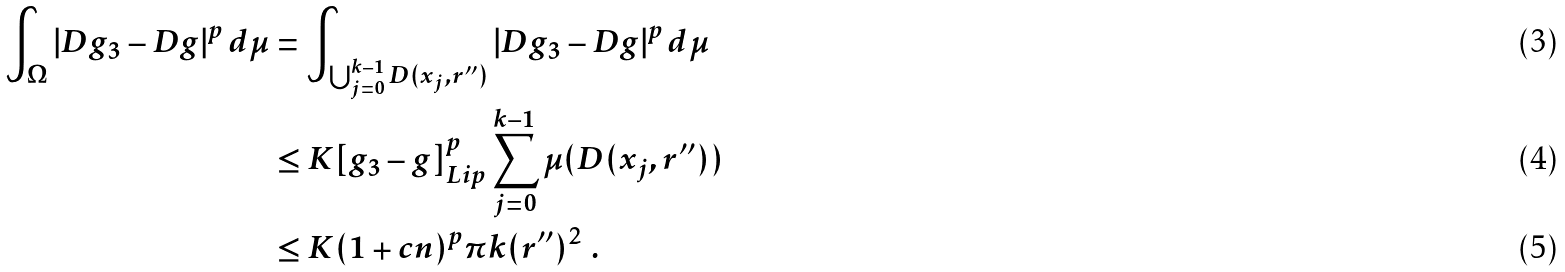Convert formula to latex. <formula><loc_0><loc_0><loc_500><loc_500>\int _ { \Omega } | D g _ { 3 } - D g | ^ { p } \, d \mu & = \int _ { \bigcup _ { j = 0 } ^ { k - 1 } D ( x _ { j } , r ^ { \prime \prime } ) } | D g _ { 3 } - D g | ^ { p } \, d \mu \\ & \leq K [ g _ { 3 } - g ] _ { L i p } ^ { p } \sum _ { j = 0 } ^ { k - 1 } \mu ( D ( x _ { j } , r ^ { \prime \prime } ) ) \\ & \leq K ( 1 + c n ) ^ { p } \pi k ( r ^ { \prime \prime } ) ^ { 2 } \ .</formula> 